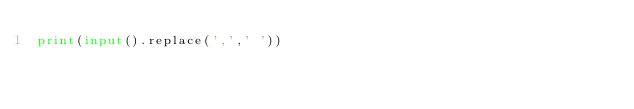<code> <loc_0><loc_0><loc_500><loc_500><_Python_>print(input().replace(',',' '))
</code> 